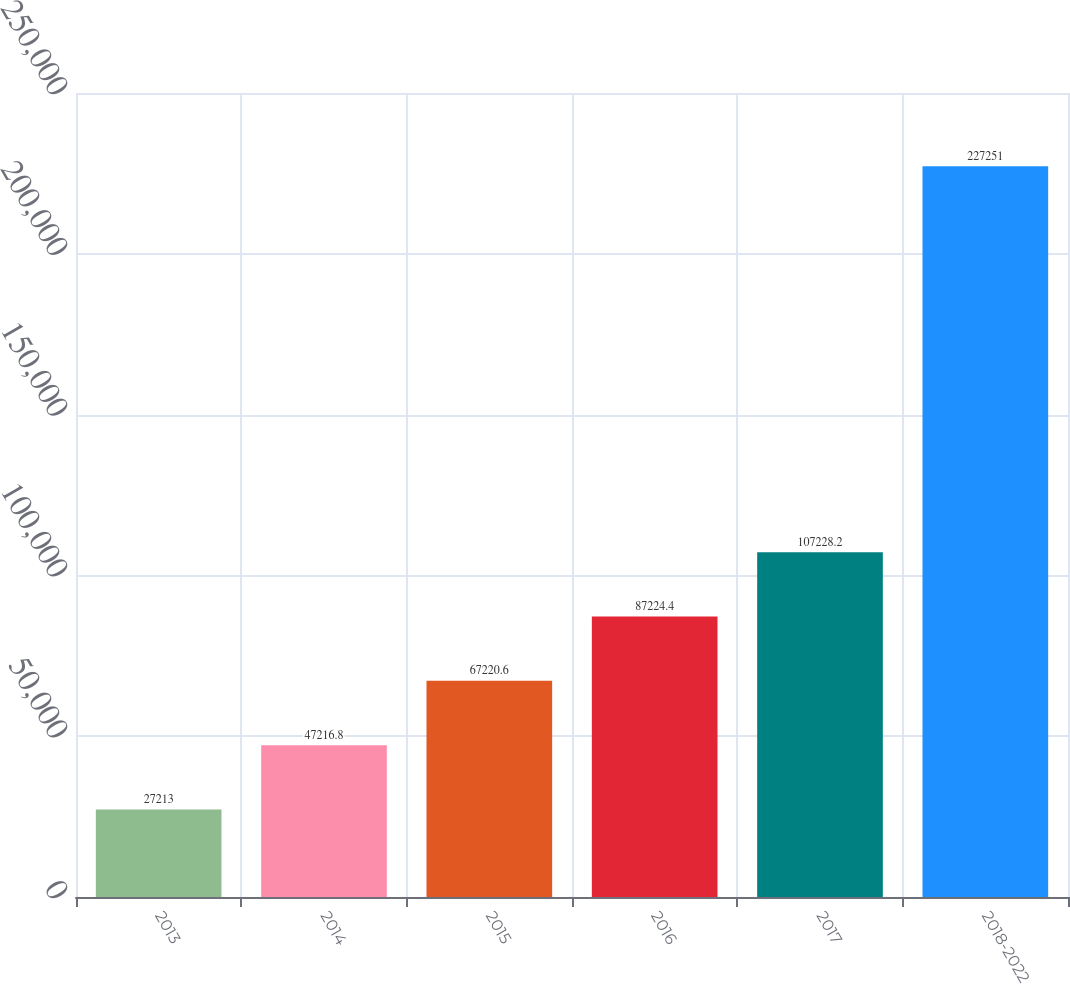Convert chart. <chart><loc_0><loc_0><loc_500><loc_500><bar_chart><fcel>2013<fcel>2014<fcel>2015<fcel>2016<fcel>2017<fcel>2018-2022<nl><fcel>27213<fcel>47216.8<fcel>67220.6<fcel>87224.4<fcel>107228<fcel>227251<nl></chart> 